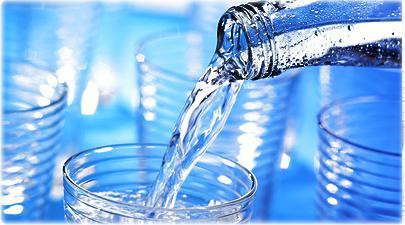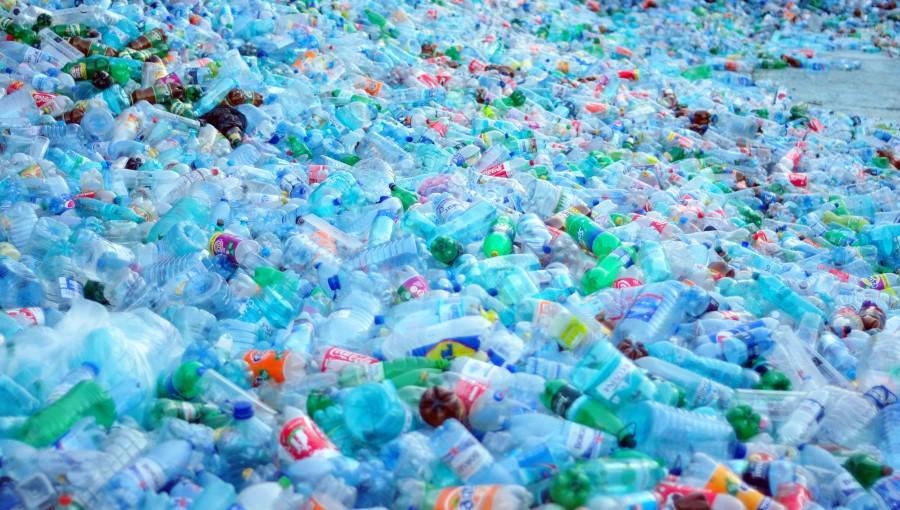The first image is the image on the left, the second image is the image on the right. Considering the images on both sides, is "An image shows water that is not inside a bottle." valid? Answer yes or no. Yes. 